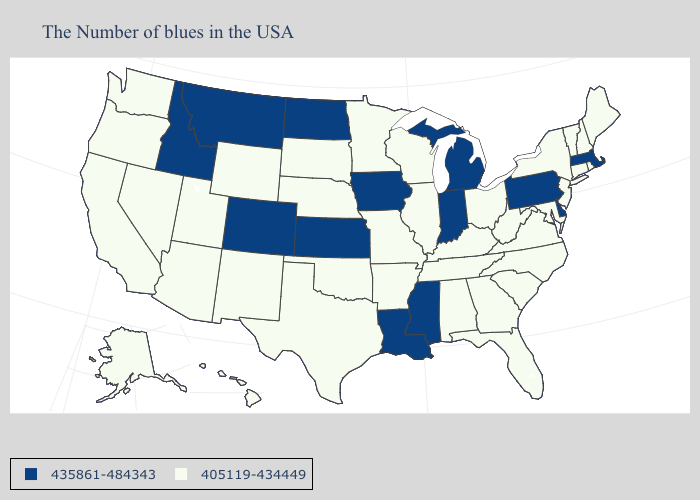Does Oklahoma have the lowest value in the South?
Be succinct. Yes. What is the value of Wyoming?
Quick response, please. 405119-434449. What is the lowest value in the Northeast?
Answer briefly. 405119-434449. Which states have the lowest value in the USA?
Be succinct. Maine, Rhode Island, New Hampshire, Vermont, Connecticut, New York, New Jersey, Maryland, Virginia, North Carolina, South Carolina, West Virginia, Ohio, Florida, Georgia, Kentucky, Alabama, Tennessee, Wisconsin, Illinois, Missouri, Arkansas, Minnesota, Nebraska, Oklahoma, Texas, South Dakota, Wyoming, New Mexico, Utah, Arizona, Nevada, California, Washington, Oregon, Alaska, Hawaii. Name the states that have a value in the range 435861-484343?
Be succinct. Massachusetts, Delaware, Pennsylvania, Michigan, Indiana, Mississippi, Louisiana, Iowa, Kansas, North Dakota, Colorado, Montana, Idaho. What is the highest value in states that border Texas?
Answer briefly. 435861-484343. Name the states that have a value in the range 435861-484343?
Concise answer only. Massachusetts, Delaware, Pennsylvania, Michigan, Indiana, Mississippi, Louisiana, Iowa, Kansas, North Dakota, Colorado, Montana, Idaho. Does North Dakota have the same value as Delaware?
Answer briefly. Yes. Name the states that have a value in the range 405119-434449?
Keep it brief. Maine, Rhode Island, New Hampshire, Vermont, Connecticut, New York, New Jersey, Maryland, Virginia, North Carolina, South Carolina, West Virginia, Ohio, Florida, Georgia, Kentucky, Alabama, Tennessee, Wisconsin, Illinois, Missouri, Arkansas, Minnesota, Nebraska, Oklahoma, Texas, South Dakota, Wyoming, New Mexico, Utah, Arizona, Nevada, California, Washington, Oregon, Alaska, Hawaii. Does the first symbol in the legend represent the smallest category?
Quick response, please. No. What is the lowest value in the West?
Answer briefly. 405119-434449. Does Maryland have the lowest value in the USA?
Be succinct. Yes. What is the value of Wyoming?
Quick response, please. 405119-434449. What is the value of Alabama?
Write a very short answer. 405119-434449. Among the states that border Vermont , does Massachusetts have the lowest value?
Short answer required. No. 